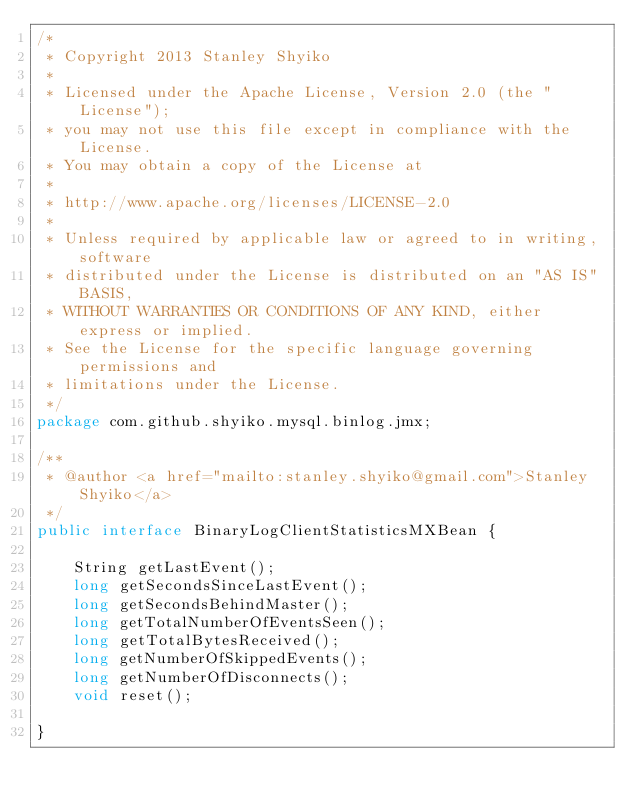<code> <loc_0><loc_0><loc_500><loc_500><_Java_>/*
 * Copyright 2013 Stanley Shyiko
 *
 * Licensed under the Apache License, Version 2.0 (the "License");
 * you may not use this file except in compliance with the License.
 * You may obtain a copy of the License at
 *
 * http://www.apache.org/licenses/LICENSE-2.0
 *
 * Unless required by applicable law or agreed to in writing, software
 * distributed under the License is distributed on an "AS IS" BASIS,
 * WITHOUT WARRANTIES OR CONDITIONS OF ANY KIND, either express or implied.
 * See the License for the specific language governing permissions and
 * limitations under the License.
 */
package com.github.shyiko.mysql.binlog.jmx;

/**
 * @author <a href="mailto:stanley.shyiko@gmail.com">Stanley Shyiko</a>
 */
public interface BinaryLogClientStatisticsMXBean {

    String getLastEvent();
    long getSecondsSinceLastEvent();
    long getSecondsBehindMaster();
    long getTotalNumberOfEventsSeen();
    long getTotalBytesReceived();
    long getNumberOfSkippedEvents();
    long getNumberOfDisconnects();
    void reset();

}
</code> 